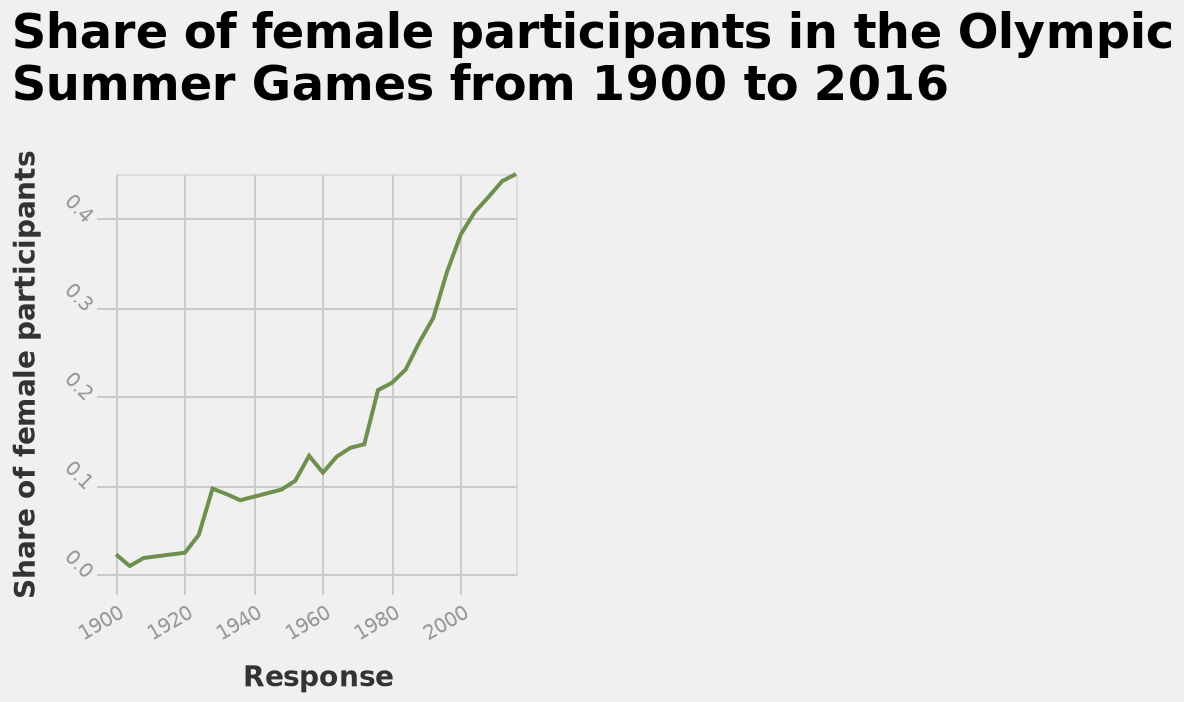<image>
What was the value of the lowest point for the share of female participants? The lowest point for the share of female participants was less than 0.01. What does the y-axis represent in the line diagram? The y-axis represents the share of female participants. 